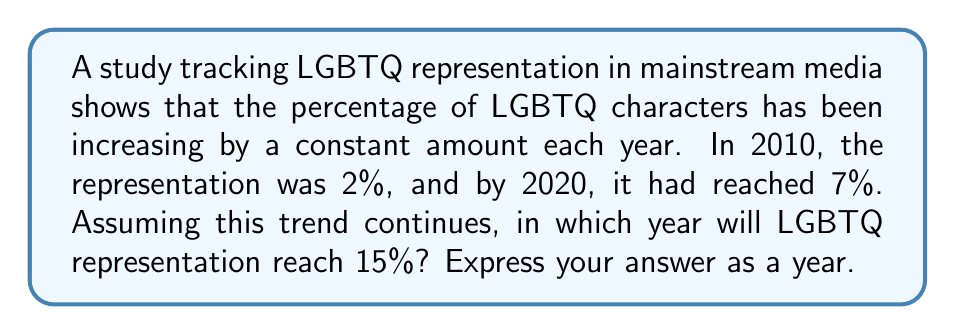Show me your answer to this math problem. Let's approach this step-by-step:

1) First, we need to find the annual increase in representation.
   Change over 10 years = 7% - 2% = 5%
   Annual increase = 5% / 10 years = 0.5% per year

2) We can represent this as an arithmetic sequence:
   $a_n = a_1 + (n-1)d$
   Where $a_n$ is the percentage in the nth year, $a_1 = 2%$, and $d = 0.5%$

3) We want to find n when $a_n = 15%$:
   $15 = 2 + (n-1)0.5$

4) Solve for n:
   $13 = (n-1)0.5$
   $26 = n-1$
   $n = 27$

5) Since n = 1 corresponds to 2010, we add 26 to 2010:
   2010 + 26 = 2036

Therefore, if the trend continues, LGBTQ representation will reach 15% in 2036.
Answer: 2036 